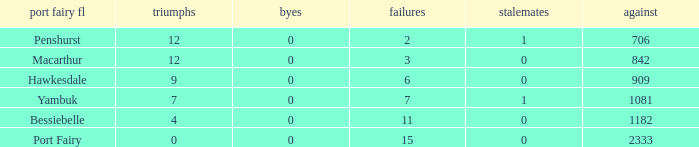How many wins for Port Fairy and against more than 2333? None. 